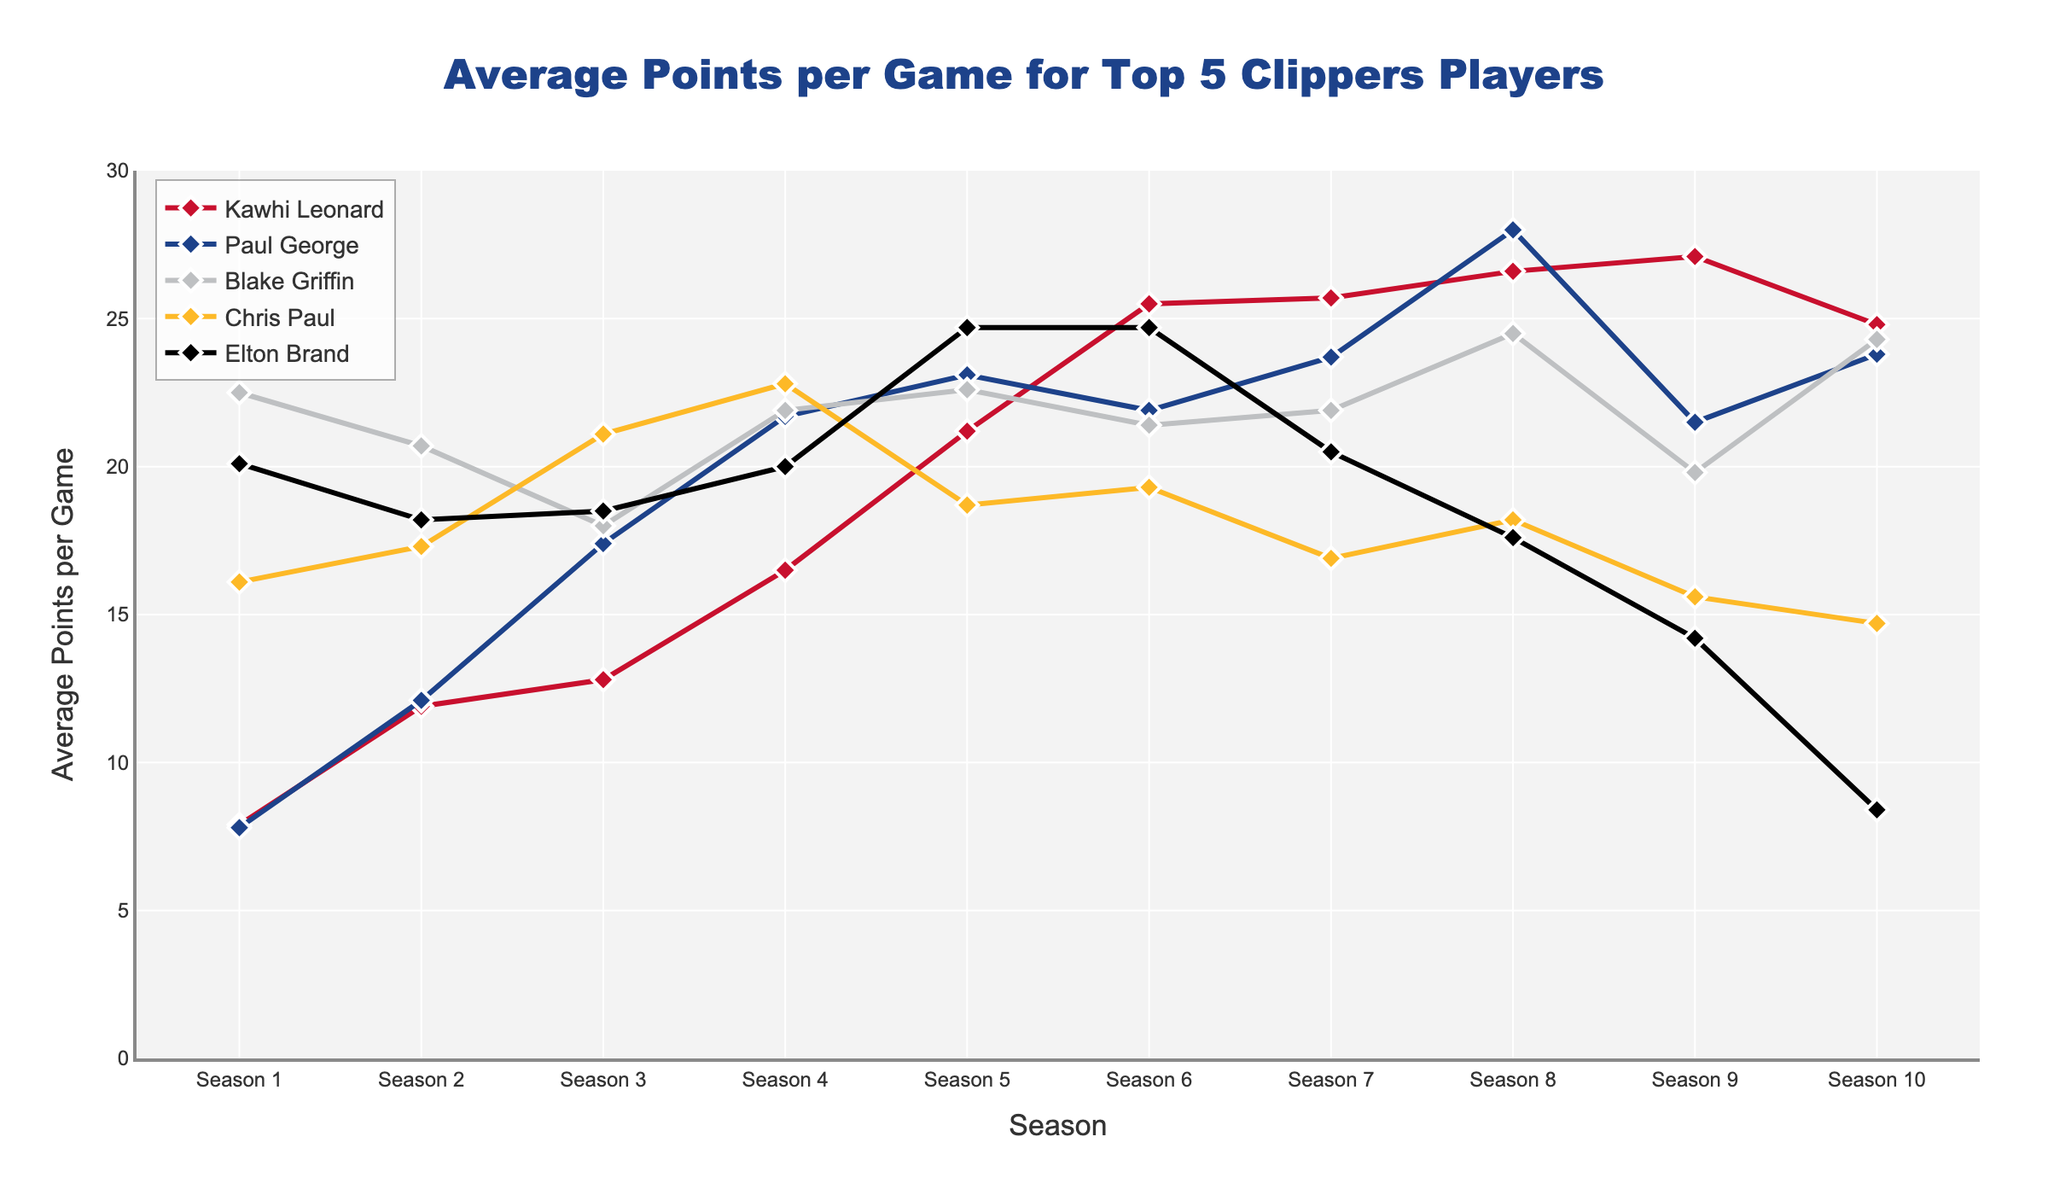What's the highest average points per game for Kawhi Leonard? To get the highest average points per game for Kawhi Leonard, we need to look at his points for each season and pick the maximum value. These values are: 7.9, 11.9, 12.8, 16.5, 21.2, 25.5, 25.7, 26.6, 27.1, 24.8. The highest value is 27.1.
Answer: 27.1 Which player had the highest average points per game in Season 4? Examine the average points per game for each player in Season 4: Kawhi Leonard (16.5), Paul George (21.7), Blake Griffin (21.9), Chris Paul (22.8), Elton Brand (20.0). Chris Paul had the highest value (22.8).
Answer: Chris Paul Who's the player with the lowest average points per game in their final season among the top 5? Check their average points per game in the last season (Season 10): Kawhi Leonard (24.8), Paul George (23.8), Blake Griffin (24.3), Chris Paul (14.7), Elton Brand (8.4). The lowest value is 8.4 by Elton Brand.
Answer: Elton Brand In which season did Paul George have his highest average points per game? We need to look at Paul George's statistics for each season and find the maximum value: 7.8, 12.1, 17.4, 21.7, 23.1, 21.9, 23.7, 28.0, 21.5, 23.8. The highest value (28.0) occurred in Season 8.
Answer: Season 8 How does Blake Griffin's average points per game in Season 6 compare to his average in Season 9? Blake Griffin's average points per game in Season 6 is 21.4 and in Season 9 is 19.8. Comparing the two, 21.4 is greater than 19.8.
Answer: Greater in Season 6 Which player had the most consistent scoring (smallest range) over their 10 seasons? The range is the difference between the highest and lowest values for each player. Calculate the range for each: Kawhi Leonard: 27.1 - 7.9 = 19.2, Paul George: 28.0 - 7.8 = 20.2, Blake Griffin: 24.5 - 18.0 = 6.5, Chris Paul: 22.8 - 14.7 = 8.1, Elton Brand: 24.7 - 8.4 = 16.3. Blake Griffin has the smallest range (6.5).
Answer: Blake Griffin What is the average points per game across all seasons for Elton Brand? Sum up Elton Brand's points for each season (20.1 + 18.2 + 18.5 + 20.0 + 24.7 + 24.7 + 20.5 + 17.6 + 14.2 + 8.4) = 187.9. Divide by the number of seasons (187.9 / 10 = 18.79).
Answer: 18.79 